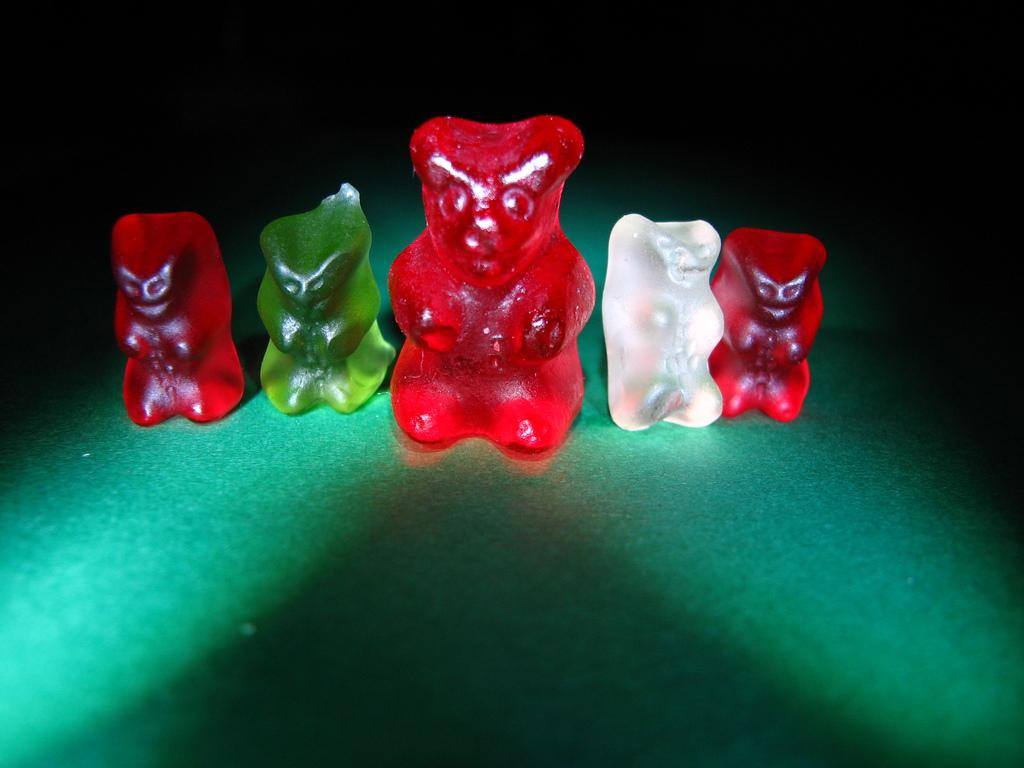What type of food is visible in the image? There are jellies in the image. Where are the jellies located? The jellies are on a surface. What is the sister of the jellies doing in the image? There is no mention of a sister or any other person in the image; it only features jellies on a surface. 